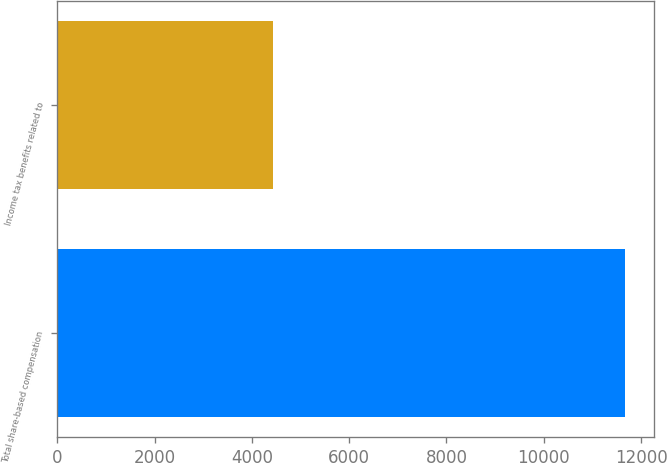Convert chart. <chart><loc_0><loc_0><loc_500><loc_500><bar_chart><fcel>Total share-based compensation<fcel>Income tax benefits related to<nl><fcel>11674<fcel>4436<nl></chart> 